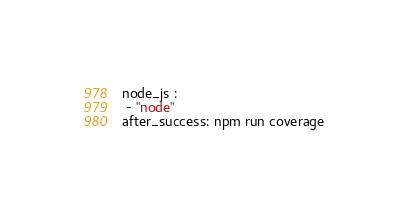<code> <loc_0><loc_0><loc_500><loc_500><_YAML_>node_js :
 - "node"
after_success: npm run coverage</code> 